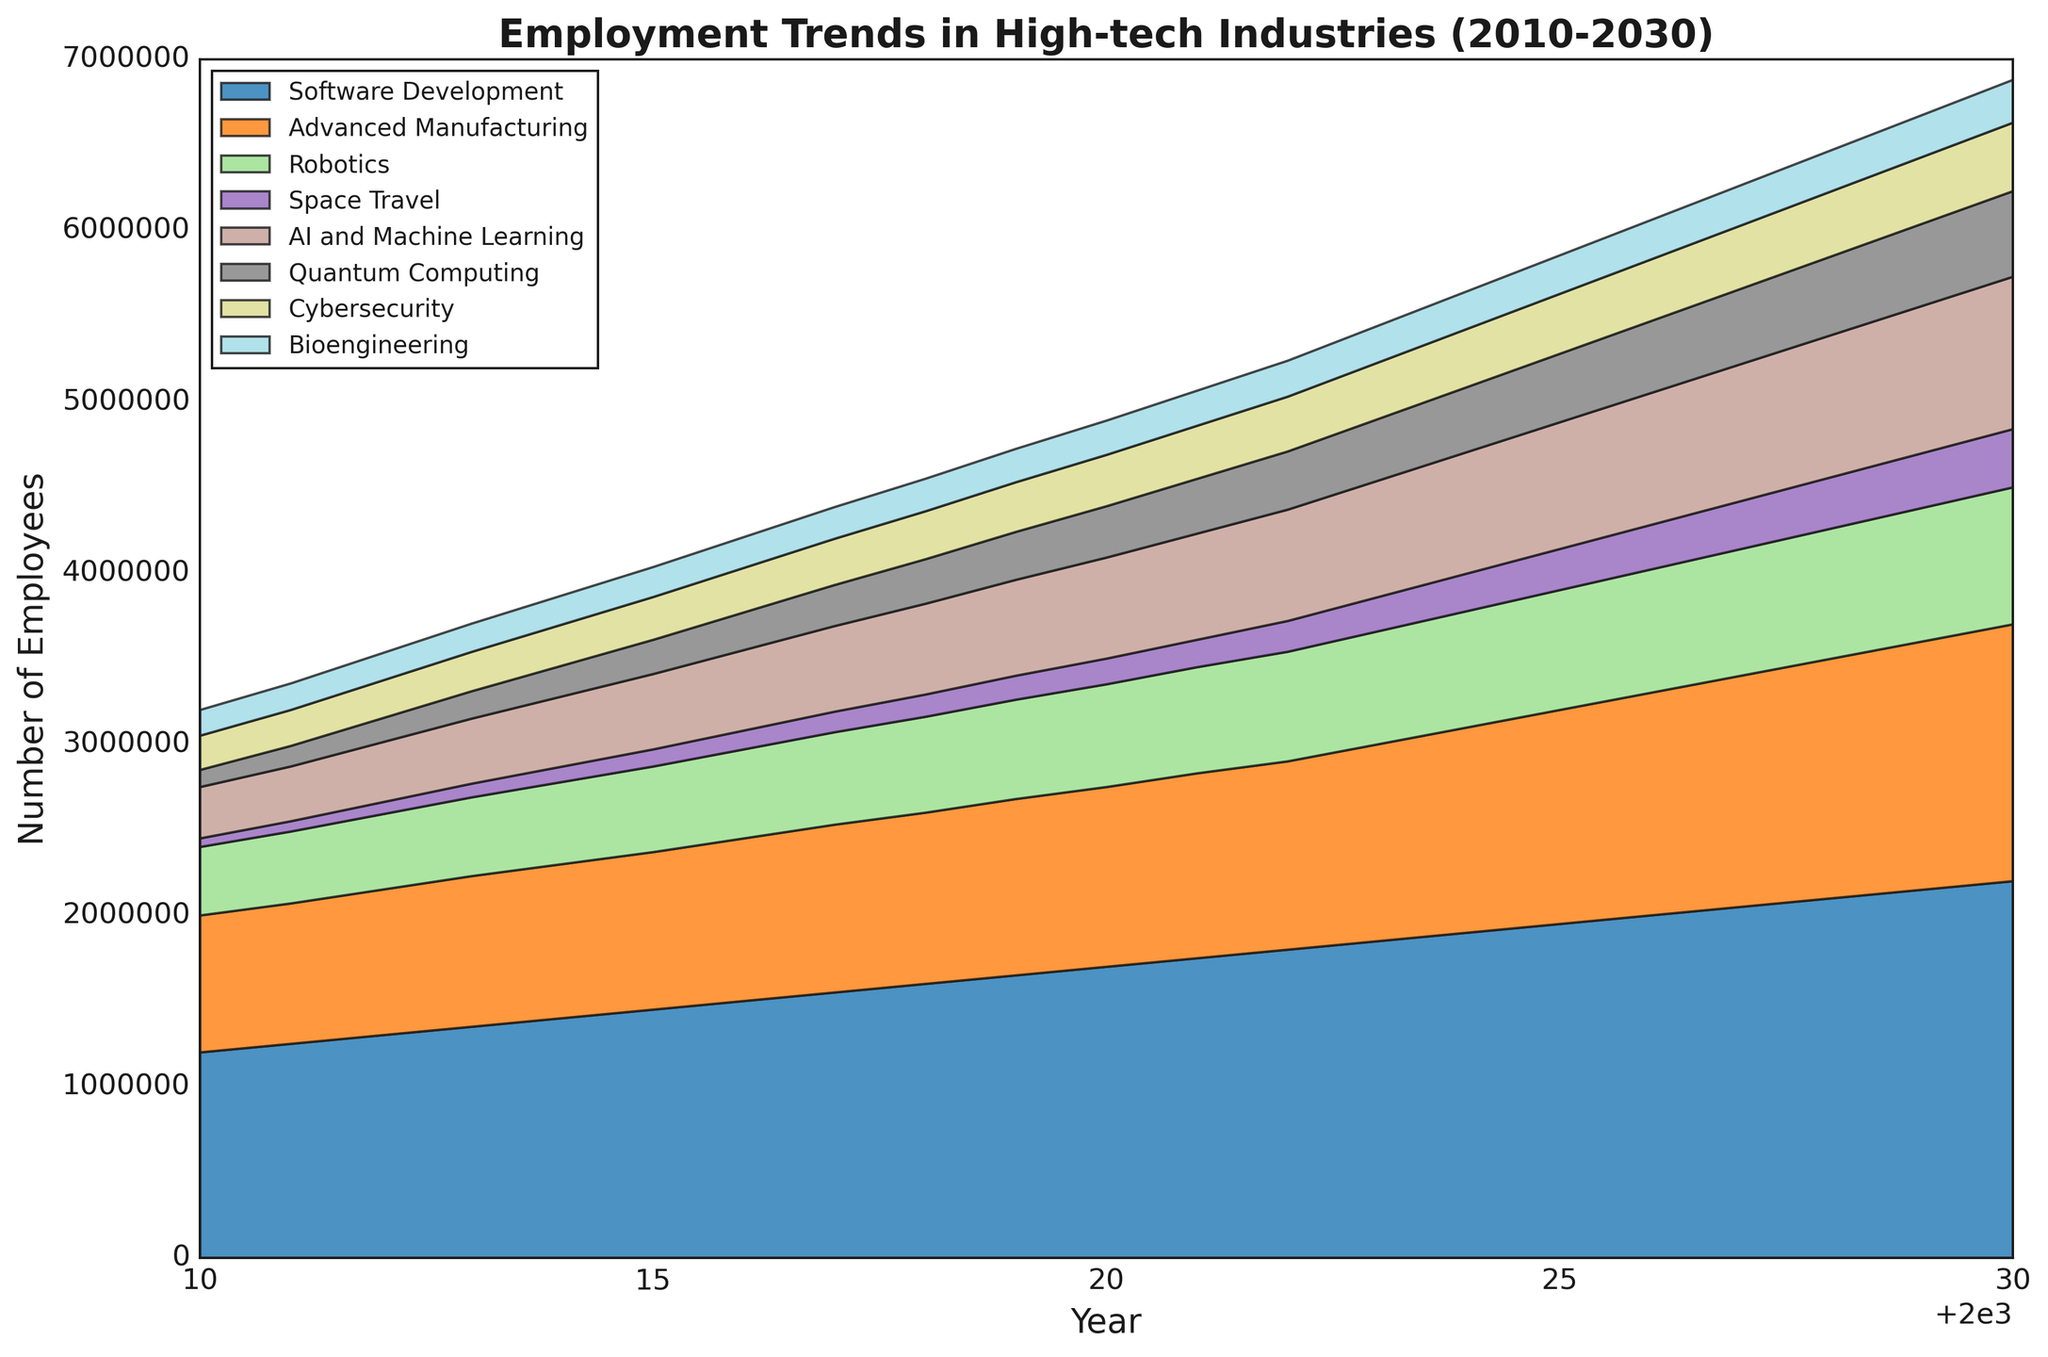Which industry had the highest number of employees in 2010? Look at the height of the colored sections in 2010. The tallest segment is for Software Development.
Answer: Software Development In what year did employment in the Space Travel industry surpass 150,000? Observe the color segment associated with Space Travel and identify the year it first exceeds 150,000 employees.
Answer: 2020 What is the combined employment in Quantum Computing and AI and Machine Learning in 2025? Find the employment values for Quantum Computing and AI and Machine Learning in 2025, and add them together: 400,000 (Quantum Computing) + 740,000 (AI and Machine Learning).
Answer: 1,140,000 Which industry shows the most significant growth between 2010 and 2030 in terms of the number of employees? Look for the industry with the largest difference in employment numbers between 2010 and 2030.
Answer: Software Development How does the 2025 employment in Cybersecurity compare to the 2025 employment in Bioengineering? Check both employment figures for 2025. Cybersecurity has 350,000 employees and Bioengineering has 225,000 employees. Cybersecurity has more.
Answer: Cybersecurity has more What is the average annual growth rate of the Robotics industry from 2010 to 2020? Determine the employment numbers for Robotics in 2010 and 2020, then calculate the compound annual growth rate over 10 years: ((600,000 / 400,000)^(1/10)) - 1.
Answer: 4.07% Which industry had minimal growth compared to others from 2010 to 2015? Look at the change in employment numbers for each industry between 2010 and 2015. The smallest absolute change is for Quantum Computing (100,000 to 200,000).
Answer: Quantum Computing By how much did the employment in Advanced Manufacturing increase between 2010 and 2022? Subtract the 2010 value from the 2022 value for Advanced Manufacturing: 1,100,000 - 800,000.
Answer: 300,000 When did the Bioengineering industry first surpass 200,000 employees? Identify the year when the Bioengineering employment segment first exceeds the 200,000 mark.
Answer: 2020 Among all industries, which had the second-highest employment in 2030? Determine the employment values for 2030 and identify the second-largest number after Software Development.
Answer: Advanced Manufacturing 